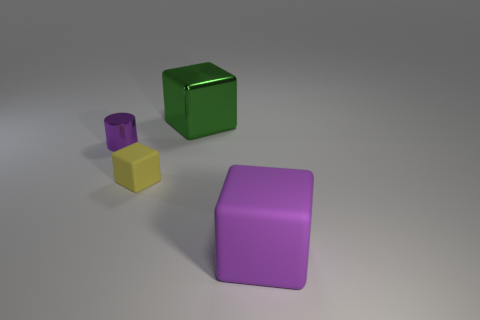Add 4 cubes. How many objects exist? 8 Subtract all cylinders. How many objects are left? 3 Subtract all large rubber objects. Subtract all big metallic cubes. How many objects are left? 2 Add 1 purple blocks. How many purple blocks are left? 2 Add 4 large purple cubes. How many large purple cubes exist? 5 Subtract 0 blue cubes. How many objects are left? 4 